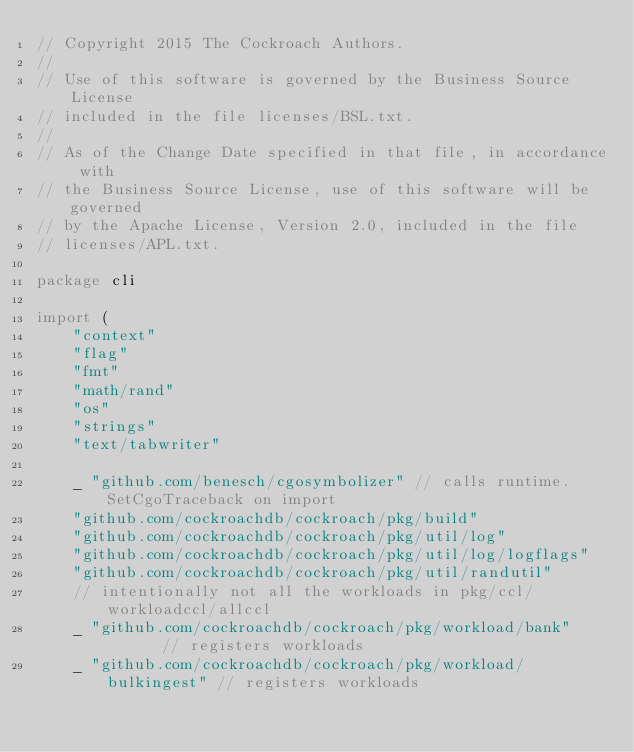Convert code to text. <code><loc_0><loc_0><loc_500><loc_500><_Go_>// Copyright 2015 The Cockroach Authors.
//
// Use of this software is governed by the Business Source License
// included in the file licenses/BSL.txt.
//
// As of the Change Date specified in that file, in accordance with
// the Business Source License, use of this software will be governed
// by the Apache License, Version 2.0, included in the file
// licenses/APL.txt.

package cli

import (
	"context"
	"flag"
	"fmt"
	"math/rand"
	"os"
	"strings"
	"text/tabwriter"

	_ "github.com/benesch/cgosymbolizer" // calls runtime.SetCgoTraceback on import
	"github.com/cockroachdb/cockroach/pkg/build"
	"github.com/cockroachdb/cockroach/pkg/util/log"
	"github.com/cockroachdb/cockroach/pkg/util/log/logflags"
	"github.com/cockroachdb/cockroach/pkg/util/randutil"
	// intentionally not all the workloads in pkg/ccl/workloadccl/allccl
	_ "github.com/cockroachdb/cockroach/pkg/workload/bank"       // registers workloads
	_ "github.com/cockroachdb/cockroach/pkg/workload/bulkingest" // registers workloads</code> 